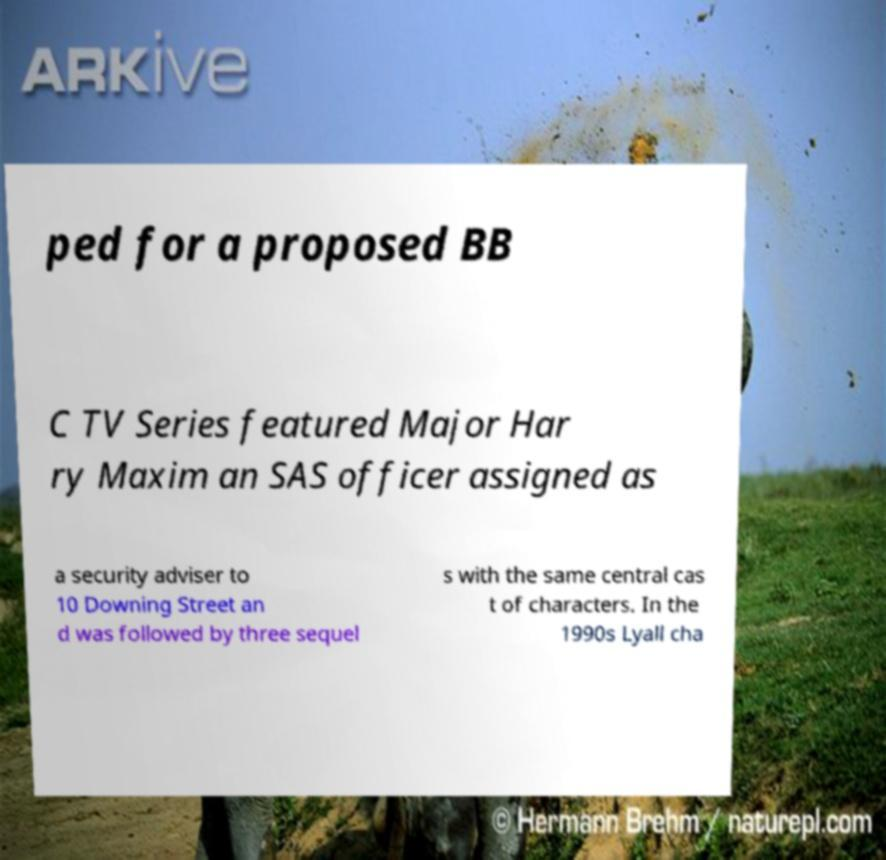For documentation purposes, I need the text within this image transcribed. Could you provide that? ped for a proposed BB C TV Series featured Major Har ry Maxim an SAS officer assigned as a security adviser to 10 Downing Street an d was followed by three sequel s with the same central cas t of characters. In the 1990s Lyall cha 